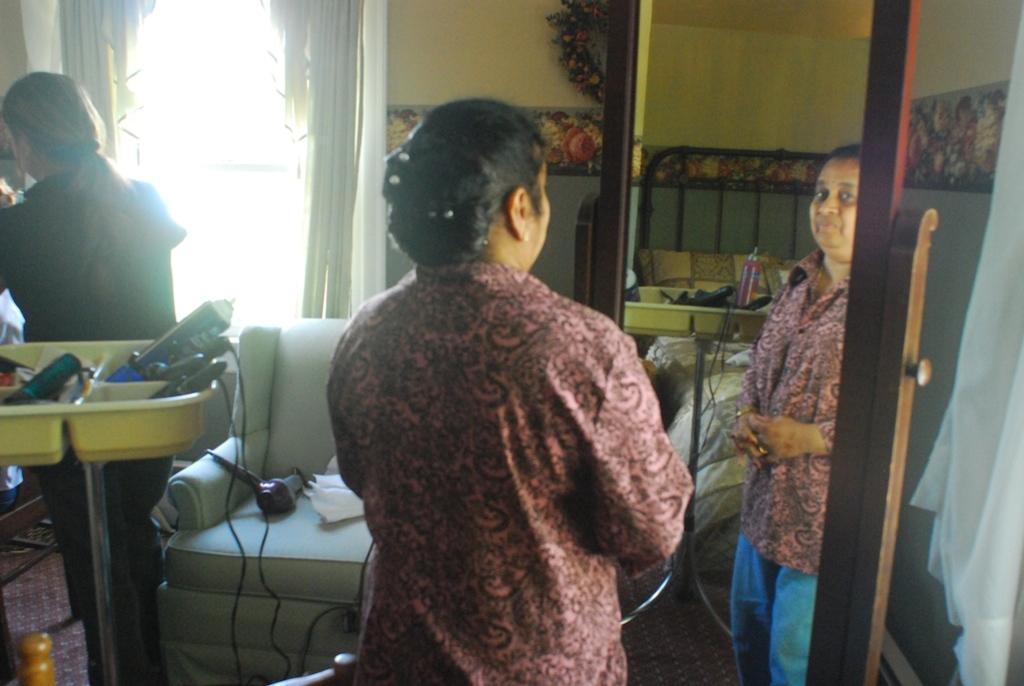Can you describe this image briefly? In the image we can see two women standing and wearing clothes. There is a mirror, in the mirror, we can see the reflection of a woman and cable wire. Here we can see hair dries and many other things placed in a tray. Here we can see window, curtains, garland and the wall. 